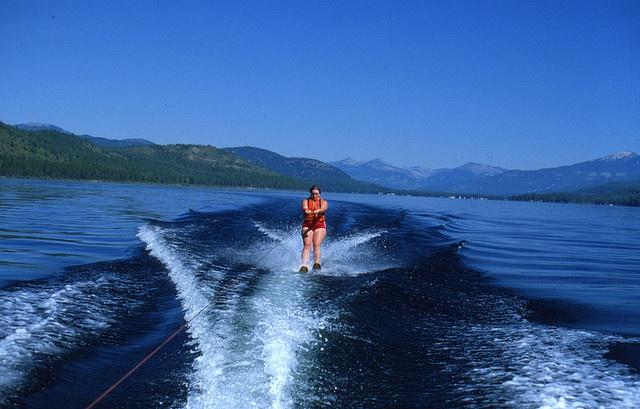Describe the objects in this image and their specific colors. I can see people in blue, lightpink, maroon, black, and brown tones and skis in blue, black, gray, darkgreen, and maroon tones in this image. 